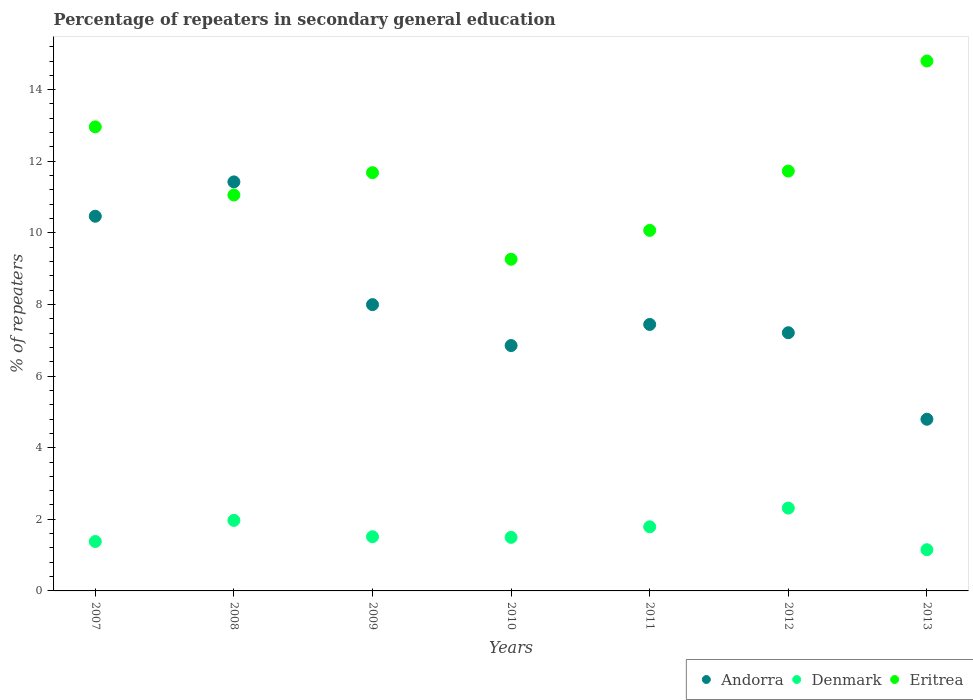How many different coloured dotlines are there?
Your response must be concise. 3. Is the number of dotlines equal to the number of legend labels?
Offer a terse response. Yes. What is the percentage of repeaters in secondary general education in Denmark in 2013?
Your answer should be compact. 1.15. Across all years, what is the maximum percentage of repeaters in secondary general education in Denmark?
Your answer should be very brief. 2.31. Across all years, what is the minimum percentage of repeaters in secondary general education in Andorra?
Give a very brief answer. 4.79. In which year was the percentage of repeaters in secondary general education in Denmark minimum?
Provide a succinct answer. 2013. What is the total percentage of repeaters in secondary general education in Denmark in the graph?
Make the answer very short. 11.61. What is the difference between the percentage of repeaters in secondary general education in Andorra in 2007 and that in 2013?
Give a very brief answer. 5.67. What is the difference between the percentage of repeaters in secondary general education in Andorra in 2013 and the percentage of repeaters in secondary general education in Eritrea in 2010?
Keep it short and to the point. -4.47. What is the average percentage of repeaters in secondary general education in Denmark per year?
Keep it short and to the point. 1.66. In the year 2008, what is the difference between the percentage of repeaters in secondary general education in Andorra and percentage of repeaters in secondary general education in Eritrea?
Your response must be concise. 0.37. What is the ratio of the percentage of repeaters in secondary general education in Andorra in 2007 to that in 2010?
Give a very brief answer. 1.53. Is the percentage of repeaters in secondary general education in Andorra in 2008 less than that in 2010?
Provide a short and direct response. No. Is the difference between the percentage of repeaters in secondary general education in Andorra in 2009 and 2011 greater than the difference between the percentage of repeaters in secondary general education in Eritrea in 2009 and 2011?
Keep it short and to the point. No. What is the difference between the highest and the second highest percentage of repeaters in secondary general education in Eritrea?
Keep it short and to the point. 1.84. What is the difference between the highest and the lowest percentage of repeaters in secondary general education in Andorra?
Ensure brevity in your answer.  6.63. In how many years, is the percentage of repeaters in secondary general education in Denmark greater than the average percentage of repeaters in secondary general education in Denmark taken over all years?
Give a very brief answer. 3. Is the sum of the percentage of repeaters in secondary general education in Andorra in 2007 and 2011 greater than the maximum percentage of repeaters in secondary general education in Denmark across all years?
Provide a short and direct response. Yes. Does the percentage of repeaters in secondary general education in Denmark monotonically increase over the years?
Offer a very short reply. No. Is the percentage of repeaters in secondary general education in Denmark strictly less than the percentage of repeaters in secondary general education in Eritrea over the years?
Provide a succinct answer. Yes. How many years are there in the graph?
Ensure brevity in your answer.  7. Are the values on the major ticks of Y-axis written in scientific E-notation?
Offer a terse response. No. Where does the legend appear in the graph?
Keep it short and to the point. Bottom right. What is the title of the graph?
Ensure brevity in your answer.  Percentage of repeaters in secondary general education. Does "Zimbabwe" appear as one of the legend labels in the graph?
Provide a short and direct response. No. What is the label or title of the X-axis?
Provide a short and direct response. Years. What is the label or title of the Y-axis?
Your answer should be compact. % of repeaters. What is the % of repeaters in Andorra in 2007?
Your answer should be compact. 10.46. What is the % of repeaters of Denmark in 2007?
Offer a very short reply. 1.38. What is the % of repeaters of Eritrea in 2007?
Give a very brief answer. 12.96. What is the % of repeaters in Andorra in 2008?
Keep it short and to the point. 11.42. What is the % of repeaters of Denmark in 2008?
Ensure brevity in your answer.  1.97. What is the % of repeaters in Eritrea in 2008?
Your answer should be very brief. 11.06. What is the % of repeaters in Andorra in 2009?
Offer a terse response. 8. What is the % of repeaters in Denmark in 2009?
Provide a short and direct response. 1.51. What is the % of repeaters in Eritrea in 2009?
Offer a very short reply. 11.68. What is the % of repeaters of Andorra in 2010?
Your response must be concise. 6.85. What is the % of repeaters in Denmark in 2010?
Keep it short and to the point. 1.5. What is the % of repeaters in Eritrea in 2010?
Keep it short and to the point. 9.26. What is the % of repeaters of Andorra in 2011?
Offer a very short reply. 7.44. What is the % of repeaters in Denmark in 2011?
Your response must be concise. 1.79. What is the % of repeaters of Eritrea in 2011?
Keep it short and to the point. 10.07. What is the % of repeaters in Andorra in 2012?
Offer a terse response. 7.21. What is the % of repeaters in Denmark in 2012?
Provide a succinct answer. 2.31. What is the % of repeaters of Eritrea in 2012?
Your answer should be compact. 11.73. What is the % of repeaters in Andorra in 2013?
Keep it short and to the point. 4.79. What is the % of repeaters in Denmark in 2013?
Your answer should be very brief. 1.15. What is the % of repeaters in Eritrea in 2013?
Provide a short and direct response. 14.8. Across all years, what is the maximum % of repeaters of Andorra?
Offer a terse response. 11.42. Across all years, what is the maximum % of repeaters in Denmark?
Ensure brevity in your answer.  2.31. Across all years, what is the maximum % of repeaters of Eritrea?
Make the answer very short. 14.8. Across all years, what is the minimum % of repeaters of Andorra?
Keep it short and to the point. 4.79. Across all years, what is the minimum % of repeaters of Denmark?
Give a very brief answer. 1.15. Across all years, what is the minimum % of repeaters in Eritrea?
Your response must be concise. 9.26. What is the total % of repeaters of Andorra in the graph?
Keep it short and to the point. 56.18. What is the total % of repeaters in Denmark in the graph?
Offer a terse response. 11.61. What is the total % of repeaters of Eritrea in the graph?
Give a very brief answer. 81.56. What is the difference between the % of repeaters of Andorra in 2007 and that in 2008?
Your answer should be compact. -0.96. What is the difference between the % of repeaters of Denmark in 2007 and that in 2008?
Keep it short and to the point. -0.59. What is the difference between the % of repeaters of Eritrea in 2007 and that in 2008?
Give a very brief answer. 1.9. What is the difference between the % of repeaters of Andorra in 2007 and that in 2009?
Give a very brief answer. 2.47. What is the difference between the % of repeaters of Denmark in 2007 and that in 2009?
Keep it short and to the point. -0.13. What is the difference between the % of repeaters of Eritrea in 2007 and that in 2009?
Give a very brief answer. 1.28. What is the difference between the % of repeaters in Andorra in 2007 and that in 2010?
Offer a terse response. 3.61. What is the difference between the % of repeaters of Denmark in 2007 and that in 2010?
Provide a succinct answer. -0.12. What is the difference between the % of repeaters in Eritrea in 2007 and that in 2010?
Provide a succinct answer. 3.7. What is the difference between the % of repeaters in Andorra in 2007 and that in 2011?
Give a very brief answer. 3.02. What is the difference between the % of repeaters of Denmark in 2007 and that in 2011?
Give a very brief answer. -0.41. What is the difference between the % of repeaters in Eritrea in 2007 and that in 2011?
Offer a very short reply. 2.89. What is the difference between the % of repeaters of Andorra in 2007 and that in 2012?
Offer a very short reply. 3.25. What is the difference between the % of repeaters of Denmark in 2007 and that in 2012?
Keep it short and to the point. -0.93. What is the difference between the % of repeaters of Eritrea in 2007 and that in 2012?
Provide a short and direct response. 1.23. What is the difference between the % of repeaters of Andorra in 2007 and that in 2013?
Your response must be concise. 5.67. What is the difference between the % of repeaters in Denmark in 2007 and that in 2013?
Ensure brevity in your answer.  0.23. What is the difference between the % of repeaters in Eritrea in 2007 and that in 2013?
Your answer should be compact. -1.84. What is the difference between the % of repeaters in Andorra in 2008 and that in 2009?
Give a very brief answer. 3.43. What is the difference between the % of repeaters of Denmark in 2008 and that in 2009?
Provide a succinct answer. 0.46. What is the difference between the % of repeaters in Eritrea in 2008 and that in 2009?
Make the answer very short. -0.62. What is the difference between the % of repeaters in Andorra in 2008 and that in 2010?
Provide a succinct answer. 4.57. What is the difference between the % of repeaters of Denmark in 2008 and that in 2010?
Offer a very short reply. 0.47. What is the difference between the % of repeaters in Eritrea in 2008 and that in 2010?
Offer a very short reply. 1.79. What is the difference between the % of repeaters in Andorra in 2008 and that in 2011?
Keep it short and to the point. 3.98. What is the difference between the % of repeaters of Denmark in 2008 and that in 2011?
Give a very brief answer. 0.18. What is the difference between the % of repeaters in Eritrea in 2008 and that in 2011?
Keep it short and to the point. 0.99. What is the difference between the % of repeaters in Andorra in 2008 and that in 2012?
Keep it short and to the point. 4.21. What is the difference between the % of repeaters of Denmark in 2008 and that in 2012?
Provide a succinct answer. -0.34. What is the difference between the % of repeaters in Eritrea in 2008 and that in 2012?
Your answer should be compact. -0.67. What is the difference between the % of repeaters in Andorra in 2008 and that in 2013?
Offer a terse response. 6.63. What is the difference between the % of repeaters in Denmark in 2008 and that in 2013?
Your response must be concise. 0.82. What is the difference between the % of repeaters in Eritrea in 2008 and that in 2013?
Keep it short and to the point. -3.74. What is the difference between the % of repeaters of Andorra in 2009 and that in 2010?
Provide a succinct answer. 1.14. What is the difference between the % of repeaters of Denmark in 2009 and that in 2010?
Provide a succinct answer. 0.02. What is the difference between the % of repeaters in Eritrea in 2009 and that in 2010?
Your answer should be very brief. 2.42. What is the difference between the % of repeaters in Andorra in 2009 and that in 2011?
Provide a succinct answer. 0.55. What is the difference between the % of repeaters in Denmark in 2009 and that in 2011?
Your answer should be compact. -0.28. What is the difference between the % of repeaters in Eritrea in 2009 and that in 2011?
Your response must be concise. 1.61. What is the difference between the % of repeaters of Andorra in 2009 and that in 2012?
Keep it short and to the point. 0.78. What is the difference between the % of repeaters of Denmark in 2009 and that in 2012?
Your answer should be very brief. -0.8. What is the difference between the % of repeaters in Eritrea in 2009 and that in 2012?
Ensure brevity in your answer.  -0.05. What is the difference between the % of repeaters of Andorra in 2009 and that in 2013?
Give a very brief answer. 3.2. What is the difference between the % of repeaters of Denmark in 2009 and that in 2013?
Give a very brief answer. 0.36. What is the difference between the % of repeaters in Eritrea in 2009 and that in 2013?
Make the answer very short. -3.12. What is the difference between the % of repeaters in Andorra in 2010 and that in 2011?
Offer a terse response. -0.59. What is the difference between the % of repeaters in Denmark in 2010 and that in 2011?
Your answer should be compact. -0.29. What is the difference between the % of repeaters in Eritrea in 2010 and that in 2011?
Your response must be concise. -0.81. What is the difference between the % of repeaters in Andorra in 2010 and that in 2012?
Offer a very short reply. -0.36. What is the difference between the % of repeaters of Denmark in 2010 and that in 2012?
Ensure brevity in your answer.  -0.82. What is the difference between the % of repeaters in Eritrea in 2010 and that in 2012?
Keep it short and to the point. -2.46. What is the difference between the % of repeaters in Andorra in 2010 and that in 2013?
Give a very brief answer. 2.06. What is the difference between the % of repeaters of Denmark in 2010 and that in 2013?
Offer a very short reply. 0.34. What is the difference between the % of repeaters in Eritrea in 2010 and that in 2013?
Your answer should be compact. -5.54. What is the difference between the % of repeaters in Andorra in 2011 and that in 2012?
Keep it short and to the point. 0.23. What is the difference between the % of repeaters of Denmark in 2011 and that in 2012?
Offer a terse response. -0.52. What is the difference between the % of repeaters of Eritrea in 2011 and that in 2012?
Your response must be concise. -1.66. What is the difference between the % of repeaters in Andorra in 2011 and that in 2013?
Offer a terse response. 2.65. What is the difference between the % of repeaters of Denmark in 2011 and that in 2013?
Offer a very short reply. 0.64. What is the difference between the % of repeaters of Eritrea in 2011 and that in 2013?
Keep it short and to the point. -4.73. What is the difference between the % of repeaters of Andorra in 2012 and that in 2013?
Keep it short and to the point. 2.42. What is the difference between the % of repeaters in Denmark in 2012 and that in 2013?
Ensure brevity in your answer.  1.16. What is the difference between the % of repeaters of Eritrea in 2012 and that in 2013?
Offer a terse response. -3.07. What is the difference between the % of repeaters in Andorra in 2007 and the % of repeaters in Denmark in 2008?
Provide a short and direct response. 8.49. What is the difference between the % of repeaters of Andorra in 2007 and the % of repeaters of Eritrea in 2008?
Make the answer very short. -0.59. What is the difference between the % of repeaters of Denmark in 2007 and the % of repeaters of Eritrea in 2008?
Give a very brief answer. -9.68. What is the difference between the % of repeaters of Andorra in 2007 and the % of repeaters of Denmark in 2009?
Your answer should be compact. 8.95. What is the difference between the % of repeaters of Andorra in 2007 and the % of repeaters of Eritrea in 2009?
Ensure brevity in your answer.  -1.22. What is the difference between the % of repeaters of Denmark in 2007 and the % of repeaters of Eritrea in 2009?
Provide a short and direct response. -10.3. What is the difference between the % of repeaters of Andorra in 2007 and the % of repeaters of Denmark in 2010?
Your answer should be compact. 8.97. What is the difference between the % of repeaters in Andorra in 2007 and the % of repeaters in Eritrea in 2010?
Ensure brevity in your answer.  1.2. What is the difference between the % of repeaters of Denmark in 2007 and the % of repeaters of Eritrea in 2010?
Provide a short and direct response. -7.88. What is the difference between the % of repeaters of Andorra in 2007 and the % of repeaters of Denmark in 2011?
Provide a short and direct response. 8.67. What is the difference between the % of repeaters in Andorra in 2007 and the % of repeaters in Eritrea in 2011?
Offer a terse response. 0.39. What is the difference between the % of repeaters in Denmark in 2007 and the % of repeaters in Eritrea in 2011?
Offer a very short reply. -8.69. What is the difference between the % of repeaters in Andorra in 2007 and the % of repeaters in Denmark in 2012?
Your answer should be very brief. 8.15. What is the difference between the % of repeaters in Andorra in 2007 and the % of repeaters in Eritrea in 2012?
Your answer should be very brief. -1.26. What is the difference between the % of repeaters of Denmark in 2007 and the % of repeaters of Eritrea in 2012?
Your answer should be very brief. -10.35. What is the difference between the % of repeaters in Andorra in 2007 and the % of repeaters in Denmark in 2013?
Your answer should be very brief. 9.31. What is the difference between the % of repeaters of Andorra in 2007 and the % of repeaters of Eritrea in 2013?
Your response must be concise. -4.34. What is the difference between the % of repeaters of Denmark in 2007 and the % of repeaters of Eritrea in 2013?
Keep it short and to the point. -13.42. What is the difference between the % of repeaters of Andorra in 2008 and the % of repeaters of Denmark in 2009?
Your response must be concise. 9.91. What is the difference between the % of repeaters of Andorra in 2008 and the % of repeaters of Eritrea in 2009?
Your answer should be very brief. -0.26. What is the difference between the % of repeaters of Denmark in 2008 and the % of repeaters of Eritrea in 2009?
Provide a short and direct response. -9.71. What is the difference between the % of repeaters of Andorra in 2008 and the % of repeaters of Denmark in 2010?
Your answer should be compact. 9.93. What is the difference between the % of repeaters of Andorra in 2008 and the % of repeaters of Eritrea in 2010?
Offer a very short reply. 2.16. What is the difference between the % of repeaters in Denmark in 2008 and the % of repeaters in Eritrea in 2010?
Your answer should be compact. -7.29. What is the difference between the % of repeaters in Andorra in 2008 and the % of repeaters in Denmark in 2011?
Make the answer very short. 9.63. What is the difference between the % of repeaters of Andorra in 2008 and the % of repeaters of Eritrea in 2011?
Keep it short and to the point. 1.35. What is the difference between the % of repeaters of Denmark in 2008 and the % of repeaters of Eritrea in 2011?
Provide a succinct answer. -8.1. What is the difference between the % of repeaters in Andorra in 2008 and the % of repeaters in Denmark in 2012?
Provide a succinct answer. 9.11. What is the difference between the % of repeaters of Andorra in 2008 and the % of repeaters of Eritrea in 2012?
Give a very brief answer. -0.3. What is the difference between the % of repeaters in Denmark in 2008 and the % of repeaters in Eritrea in 2012?
Give a very brief answer. -9.76. What is the difference between the % of repeaters in Andorra in 2008 and the % of repeaters in Denmark in 2013?
Provide a succinct answer. 10.27. What is the difference between the % of repeaters of Andorra in 2008 and the % of repeaters of Eritrea in 2013?
Provide a succinct answer. -3.38. What is the difference between the % of repeaters in Denmark in 2008 and the % of repeaters in Eritrea in 2013?
Make the answer very short. -12.83. What is the difference between the % of repeaters of Andorra in 2009 and the % of repeaters of Denmark in 2010?
Provide a succinct answer. 6.5. What is the difference between the % of repeaters in Andorra in 2009 and the % of repeaters in Eritrea in 2010?
Offer a terse response. -1.27. What is the difference between the % of repeaters in Denmark in 2009 and the % of repeaters in Eritrea in 2010?
Your response must be concise. -7.75. What is the difference between the % of repeaters in Andorra in 2009 and the % of repeaters in Denmark in 2011?
Ensure brevity in your answer.  6.2. What is the difference between the % of repeaters of Andorra in 2009 and the % of repeaters of Eritrea in 2011?
Ensure brevity in your answer.  -2.07. What is the difference between the % of repeaters in Denmark in 2009 and the % of repeaters in Eritrea in 2011?
Make the answer very short. -8.56. What is the difference between the % of repeaters of Andorra in 2009 and the % of repeaters of Denmark in 2012?
Your response must be concise. 5.68. What is the difference between the % of repeaters in Andorra in 2009 and the % of repeaters in Eritrea in 2012?
Give a very brief answer. -3.73. What is the difference between the % of repeaters of Denmark in 2009 and the % of repeaters of Eritrea in 2012?
Provide a succinct answer. -10.21. What is the difference between the % of repeaters in Andorra in 2009 and the % of repeaters in Denmark in 2013?
Make the answer very short. 6.84. What is the difference between the % of repeaters of Andorra in 2009 and the % of repeaters of Eritrea in 2013?
Ensure brevity in your answer.  -6.8. What is the difference between the % of repeaters of Denmark in 2009 and the % of repeaters of Eritrea in 2013?
Ensure brevity in your answer.  -13.29. What is the difference between the % of repeaters of Andorra in 2010 and the % of repeaters of Denmark in 2011?
Provide a short and direct response. 5.06. What is the difference between the % of repeaters in Andorra in 2010 and the % of repeaters in Eritrea in 2011?
Offer a terse response. -3.22. What is the difference between the % of repeaters of Denmark in 2010 and the % of repeaters of Eritrea in 2011?
Offer a terse response. -8.57. What is the difference between the % of repeaters of Andorra in 2010 and the % of repeaters of Denmark in 2012?
Ensure brevity in your answer.  4.54. What is the difference between the % of repeaters in Andorra in 2010 and the % of repeaters in Eritrea in 2012?
Your answer should be very brief. -4.87. What is the difference between the % of repeaters of Denmark in 2010 and the % of repeaters of Eritrea in 2012?
Give a very brief answer. -10.23. What is the difference between the % of repeaters of Andorra in 2010 and the % of repeaters of Denmark in 2013?
Offer a terse response. 5.7. What is the difference between the % of repeaters in Andorra in 2010 and the % of repeaters in Eritrea in 2013?
Your answer should be very brief. -7.95. What is the difference between the % of repeaters of Denmark in 2010 and the % of repeaters of Eritrea in 2013?
Give a very brief answer. -13.3. What is the difference between the % of repeaters in Andorra in 2011 and the % of repeaters in Denmark in 2012?
Give a very brief answer. 5.13. What is the difference between the % of repeaters in Andorra in 2011 and the % of repeaters in Eritrea in 2012?
Give a very brief answer. -4.28. What is the difference between the % of repeaters of Denmark in 2011 and the % of repeaters of Eritrea in 2012?
Offer a terse response. -9.94. What is the difference between the % of repeaters in Andorra in 2011 and the % of repeaters in Denmark in 2013?
Your answer should be very brief. 6.29. What is the difference between the % of repeaters in Andorra in 2011 and the % of repeaters in Eritrea in 2013?
Provide a succinct answer. -7.36. What is the difference between the % of repeaters of Denmark in 2011 and the % of repeaters of Eritrea in 2013?
Make the answer very short. -13.01. What is the difference between the % of repeaters of Andorra in 2012 and the % of repeaters of Denmark in 2013?
Your answer should be very brief. 6.06. What is the difference between the % of repeaters in Andorra in 2012 and the % of repeaters in Eritrea in 2013?
Keep it short and to the point. -7.59. What is the difference between the % of repeaters of Denmark in 2012 and the % of repeaters of Eritrea in 2013?
Offer a very short reply. -12.49. What is the average % of repeaters of Andorra per year?
Your answer should be very brief. 8.03. What is the average % of repeaters of Denmark per year?
Ensure brevity in your answer.  1.66. What is the average % of repeaters of Eritrea per year?
Give a very brief answer. 11.65. In the year 2007, what is the difference between the % of repeaters of Andorra and % of repeaters of Denmark?
Your answer should be very brief. 9.08. In the year 2007, what is the difference between the % of repeaters of Andorra and % of repeaters of Eritrea?
Ensure brevity in your answer.  -2.5. In the year 2007, what is the difference between the % of repeaters in Denmark and % of repeaters in Eritrea?
Your answer should be very brief. -11.58. In the year 2008, what is the difference between the % of repeaters of Andorra and % of repeaters of Denmark?
Provide a succinct answer. 9.45. In the year 2008, what is the difference between the % of repeaters of Andorra and % of repeaters of Eritrea?
Offer a very short reply. 0.37. In the year 2008, what is the difference between the % of repeaters in Denmark and % of repeaters in Eritrea?
Provide a short and direct response. -9.09. In the year 2009, what is the difference between the % of repeaters of Andorra and % of repeaters of Denmark?
Keep it short and to the point. 6.48. In the year 2009, what is the difference between the % of repeaters of Andorra and % of repeaters of Eritrea?
Provide a succinct answer. -3.69. In the year 2009, what is the difference between the % of repeaters of Denmark and % of repeaters of Eritrea?
Your response must be concise. -10.17. In the year 2010, what is the difference between the % of repeaters of Andorra and % of repeaters of Denmark?
Give a very brief answer. 5.36. In the year 2010, what is the difference between the % of repeaters in Andorra and % of repeaters in Eritrea?
Ensure brevity in your answer.  -2.41. In the year 2010, what is the difference between the % of repeaters in Denmark and % of repeaters in Eritrea?
Make the answer very short. -7.77. In the year 2011, what is the difference between the % of repeaters in Andorra and % of repeaters in Denmark?
Provide a short and direct response. 5.65. In the year 2011, what is the difference between the % of repeaters in Andorra and % of repeaters in Eritrea?
Your answer should be compact. -2.63. In the year 2011, what is the difference between the % of repeaters of Denmark and % of repeaters of Eritrea?
Ensure brevity in your answer.  -8.28. In the year 2012, what is the difference between the % of repeaters in Andorra and % of repeaters in Denmark?
Ensure brevity in your answer.  4.9. In the year 2012, what is the difference between the % of repeaters of Andorra and % of repeaters of Eritrea?
Your answer should be compact. -4.52. In the year 2012, what is the difference between the % of repeaters in Denmark and % of repeaters in Eritrea?
Ensure brevity in your answer.  -9.41. In the year 2013, what is the difference between the % of repeaters in Andorra and % of repeaters in Denmark?
Your answer should be compact. 3.64. In the year 2013, what is the difference between the % of repeaters in Andorra and % of repeaters in Eritrea?
Offer a very short reply. -10.01. In the year 2013, what is the difference between the % of repeaters of Denmark and % of repeaters of Eritrea?
Offer a terse response. -13.65. What is the ratio of the % of repeaters of Andorra in 2007 to that in 2008?
Your answer should be very brief. 0.92. What is the ratio of the % of repeaters in Denmark in 2007 to that in 2008?
Provide a short and direct response. 0.7. What is the ratio of the % of repeaters in Eritrea in 2007 to that in 2008?
Provide a short and direct response. 1.17. What is the ratio of the % of repeaters of Andorra in 2007 to that in 2009?
Keep it short and to the point. 1.31. What is the ratio of the % of repeaters in Denmark in 2007 to that in 2009?
Your response must be concise. 0.91. What is the ratio of the % of repeaters of Eritrea in 2007 to that in 2009?
Your response must be concise. 1.11. What is the ratio of the % of repeaters in Andorra in 2007 to that in 2010?
Your answer should be very brief. 1.53. What is the ratio of the % of repeaters of Denmark in 2007 to that in 2010?
Provide a short and direct response. 0.92. What is the ratio of the % of repeaters of Eritrea in 2007 to that in 2010?
Your response must be concise. 1.4. What is the ratio of the % of repeaters in Andorra in 2007 to that in 2011?
Provide a succinct answer. 1.41. What is the ratio of the % of repeaters in Denmark in 2007 to that in 2011?
Offer a very short reply. 0.77. What is the ratio of the % of repeaters in Eritrea in 2007 to that in 2011?
Offer a very short reply. 1.29. What is the ratio of the % of repeaters in Andorra in 2007 to that in 2012?
Your response must be concise. 1.45. What is the ratio of the % of repeaters in Denmark in 2007 to that in 2012?
Offer a very short reply. 0.6. What is the ratio of the % of repeaters in Eritrea in 2007 to that in 2012?
Offer a terse response. 1.11. What is the ratio of the % of repeaters in Andorra in 2007 to that in 2013?
Make the answer very short. 2.18. What is the ratio of the % of repeaters of Denmark in 2007 to that in 2013?
Your answer should be very brief. 1.2. What is the ratio of the % of repeaters of Eritrea in 2007 to that in 2013?
Your answer should be compact. 0.88. What is the ratio of the % of repeaters in Andorra in 2008 to that in 2009?
Your response must be concise. 1.43. What is the ratio of the % of repeaters of Denmark in 2008 to that in 2009?
Your answer should be compact. 1.3. What is the ratio of the % of repeaters in Eritrea in 2008 to that in 2009?
Offer a very short reply. 0.95. What is the ratio of the % of repeaters of Andorra in 2008 to that in 2010?
Your response must be concise. 1.67. What is the ratio of the % of repeaters in Denmark in 2008 to that in 2010?
Offer a terse response. 1.32. What is the ratio of the % of repeaters of Eritrea in 2008 to that in 2010?
Offer a very short reply. 1.19. What is the ratio of the % of repeaters of Andorra in 2008 to that in 2011?
Your answer should be very brief. 1.53. What is the ratio of the % of repeaters of Denmark in 2008 to that in 2011?
Give a very brief answer. 1.1. What is the ratio of the % of repeaters of Eritrea in 2008 to that in 2011?
Offer a very short reply. 1.1. What is the ratio of the % of repeaters of Andorra in 2008 to that in 2012?
Offer a terse response. 1.58. What is the ratio of the % of repeaters in Denmark in 2008 to that in 2012?
Your answer should be very brief. 0.85. What is the ratio of the % of repeaters of Eritrea in 2008 to that in 2012?
Your response must be concise. 0.94. What is the ratio of the % of repeaters in Andorra in 2008 to that in 2013?
Ensure brevity in your answer.  2.38. What is the ratio of the % of repeaters of Denmark in 2008 to that in 2013?
Offer a very short reply. 1.71. What is the ratio of the % of repeaters of Eritrea in 2008 to that in 2013?
Your response must be concise. 0.75. What is the ratio of the % of repeaters of Andorra in 2009 to that in 2010?
Make the answer very short. 1.17. What is the ratio of the % of repeaters of Denmark in 2009 to that in 2010?
Provide a short and direct response. 1.01. What is the ratio of the % of repeaters in Eritrea in 2009 to that in 2010?
Provide a succinct answer. 1.26. What is the ratio of the % of repeaters in Andorra in 2009 to that in 2011?
Give a very brief answer. 1.07. What is the ratio of the % of repeaters of Denmark in 2009 to that in 2011?
Ensure brevity in your answer.  0.85. What is the ratio of the % of repeaters in Eritrea in 2009 to that in 2011?
Your answer should be compact. 1.16. What is the ratio of the % of repeaters in Andorra in 2009 to that in 2012?
Ensure brevity in your answer.  1.11. What is the ratio of the % of repeaters of Denmark in 2009 to that in 2012?
Offer a very short reply. 0.65. What is the ratio of the % of repeaters in Andorra in 2009 to that in 2013?
Keep it short and to the point. 1.67. What is the ratio of the % of repeaters in Denmark in 2009 to that in 2013?
Give a very brief answer. 1.31. What is the ratio of the % of repeaters in Eritrea in 2009 to that in 2013?
Offer a terse response. 0.79. What is the ratio of the % of repeaters of Andorra in 2010 to that in 2011?
Give a very brief answer. 0.92. What is the ratio of the % of repeaters of Denmark in 2010 to that in 2011?
Your answer should be very brief. 0.84. What is the ratio of the % of repeaters of Eritrea in 2010 to that in 2011?
Keep it short and to the point. 0.92. What is the ratio of the % of repeaters of Andorra in 2010 to that in 2012?
Offer a very short reply. 0.95. What is the ratio of the % of repeaters in Denmark in 2010 to that in 2012?
Keep it short and to the point. 0.65. What is the ratio of the % of repeaters of Eritrea in 2010 to that in 2012?
Ensure brevity in your answer.  0.79. What is the ratio of the % of repeaters of Andorra in 2010 to that in 2013?
Provide a succinct answer. 1.43. What is the ratio of the % of repeaters in Denmark in 2010 to that in 2013?
Your response must be concise. 1.3. What is the ratio of the % of repeaters in Eritrea in 2010 to that in 2013?
Your answer should be very brief. 0.63. What is the ratio of the % of repeaters in Andorra in 2011 to that in 2012?
Provide a short and direct response. 1.03. What is the ratio of the % of repeaters of Denmark in 2011 to that in 2012?
Give a very brief answer. 0.77. What is the ratio of the % of repeaters in Eritrea in 2011 to that in 2012?
Your answer should be compact. 0.86. What is the ratio of the % of repeaters in Andorra in 2011 to that in 2013?
Offer a terse response. 1.55. What is the ratio of the % of repeaters of Denmark in 2011 to that in 2013?
Offer a terse response. 1.56. What is the ratio of the % of repeaters of Eritrea in 2011 to that in 2013?
Provide a succinct answer. 0.68. What is the ratio of the % of repeaters of Andorra in 2012 to that in 2013?
Your answer should be very brief. 1.5. What is the ratio of the % of repeaters of Denmark in 2012 to that in 2013?
Keep it short and to the point. 2.01. What is the ratio of the % of repeaters in Eritrea in 2012 to that in 2013?
Give a very brief answer. 0.79. What is the difference between the highest and the second highest % of repeaters in Andorra?
Offer a very short reply. 0.96. What is the difference between the highest and the second highest % of repeaters in Denmark?
Provide a succinct answer. 0.34. What is the difference between the highest and the second highest % of repeaters of Eritrea?
Offer a terse response. 1.84. What is the difference between the highest and the lowest % of repeaters in Andorra?
Make the answer very short. 6.63. What is the difference between the highest and the lowest % of repeaters of Denmark?
Ensure brevity in your answer.  1.16. What is the difference between the highest and the lowest % of repeaters of Eritrea?
Give a very brief answer. 5.54. 